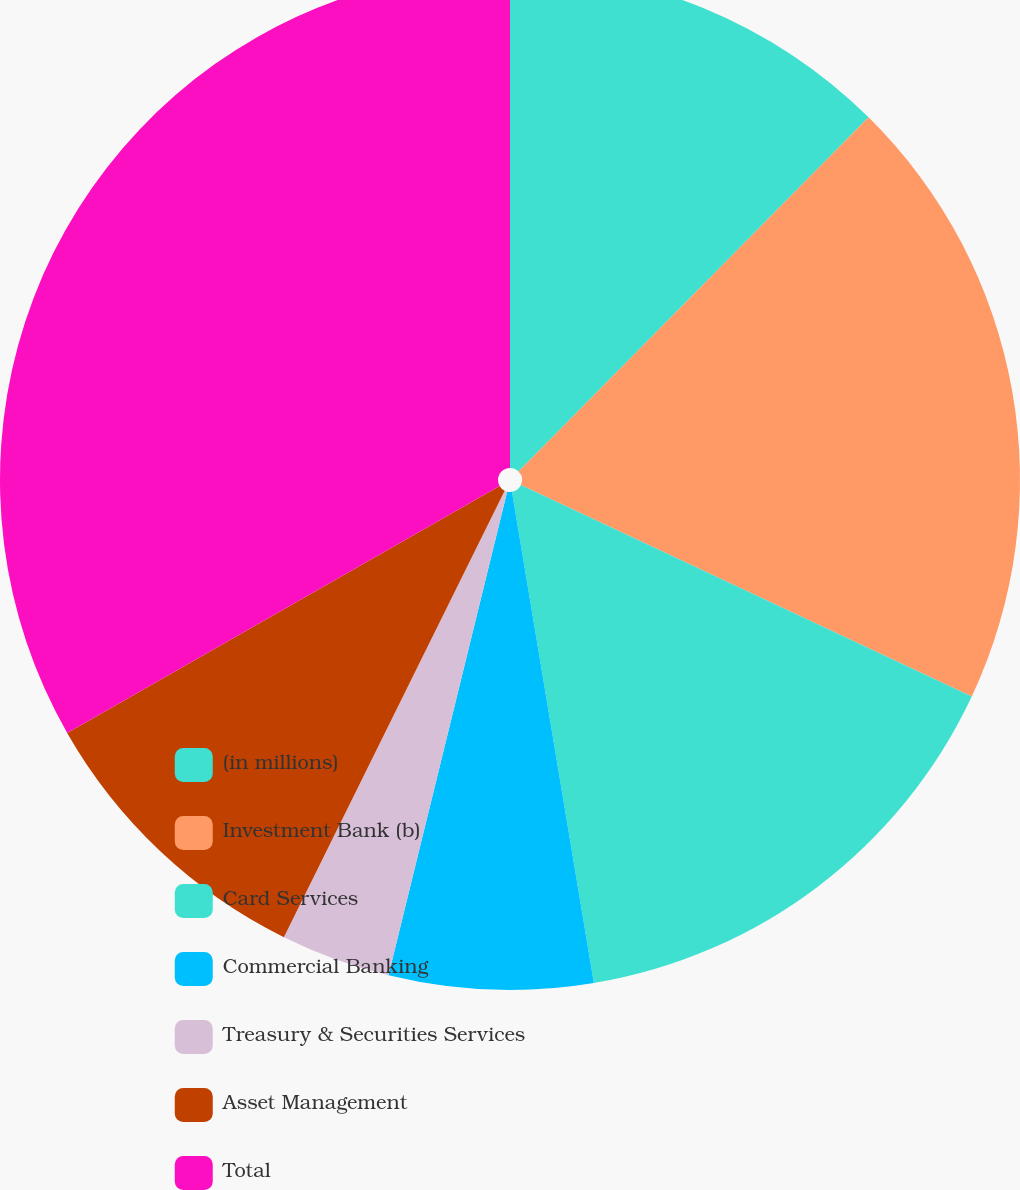Convert chart to OTSL. <chart><loc_0><loc_0><loc_500><loc_500><pie_chart><fcel>(in millions)<fcel>Investment Bank (b)<fcel>Card Services<fcel>Commercial Banking<fcel>Treasury & Securities Services<fcel>Asset Management<fcel>Total<nl><fcel>12.41%<fcel>19.57%<fcel>15.39%<fcel>6.46%<fcel>3.48%<fcel>9.43%<fcel>33.26%<nl></chart> 